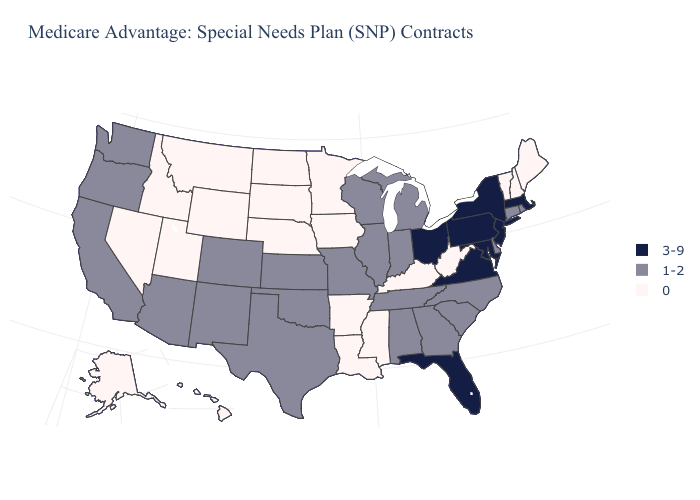Which states have the lowest value in the West?
Keep it brief. Alaska, Hawaii, Idaho, Montana, Nevada, Utah, Wyoming. Name the states that have a value in the range 1-2?
Write a very short answer. Alabama, Arizona, California, Colorado, Connecticut, Delaware, Georgia, Illinois, Indiana, Kansas, Michigan, Missouri, North Carolina, New Mexico, Oklahoma, Oregon, Rhode Island, South Carolina, Tennessee, Texas, Washington, Wisconsin. Name the states that have a value in the range 1-2?
Be succinct. Alabama, Arizona, California, Colorado, Connecticut, Delaware, Georgia, Illinois, Indiana, Kansas, Michigan, Missouri, North Carolina, New Mexico, Oklahoma, Oregon, Rhode Island, South Carolina, Tennessee, Texas, Washington, Wisconsin. Does the first symbol in the legend represent the smallest category?
Keep it brief. No. Name the states that have a value in the range 0?
Short answer required. Alaska, Arkansas, Hawaii, Iowa, Idaho, Kentucky, Louisiana, Maine, Minnesota, Mississippi, Montana, North Dakota, Nebraska, New Hampshire, Nevada, South Dakota, Utah, Vermont, West Virginia, Wyoming. What is the value of Idaho?
Give a very brief answer. 0. Which states have the lowest value in the USA?
Give a very brief answer. Alaska, Arkansas, Hawaii, Iowa, Idaho, Kentucky, Louisiana, Maine, Minnesota, Mississippi, Montana, North Dakota, Nebraska, New Hampshire, Nevada, South Dakota, Utah, Vermont, West Virginia, Wyoming. Name the states that have a value in the range 0?
Short answer required. Alaska, Arkansas, Hawaii, Iowa, Idaho, Kentucky, Louisiana, Maine, Minnesota, Mississippi, Montana, North Dakota, Nebraska, New Hampshire, Nevada, South Dakota, Utah, Vermont, West Virginia, Wyoming. What is the value of South Carolina?
Write a very short answer. 1-2. Name the states that have a value in the range 1-2?
Write a very short answer. Alabama, Arizona, California, Colorado, Connecticut, Delaware, Georgia, Illinois, Indiana, Kansas, Michigan, Missouri, North Carolina, New Mexico, Oklahoma, Oregon, Rhode Island, South Carolina, Tennessee, Texas, Washington, Wisconsin. Is the legend a continuous bar?
Give a very brief answer. No. Does the first symbol in the legend represent the smallest category?
Short answer required. No. Does North Carolina have a higher value than Minnesota?
Quick response, please. Yes. How many symbols are there in the legend?
Short answer required. 3. 